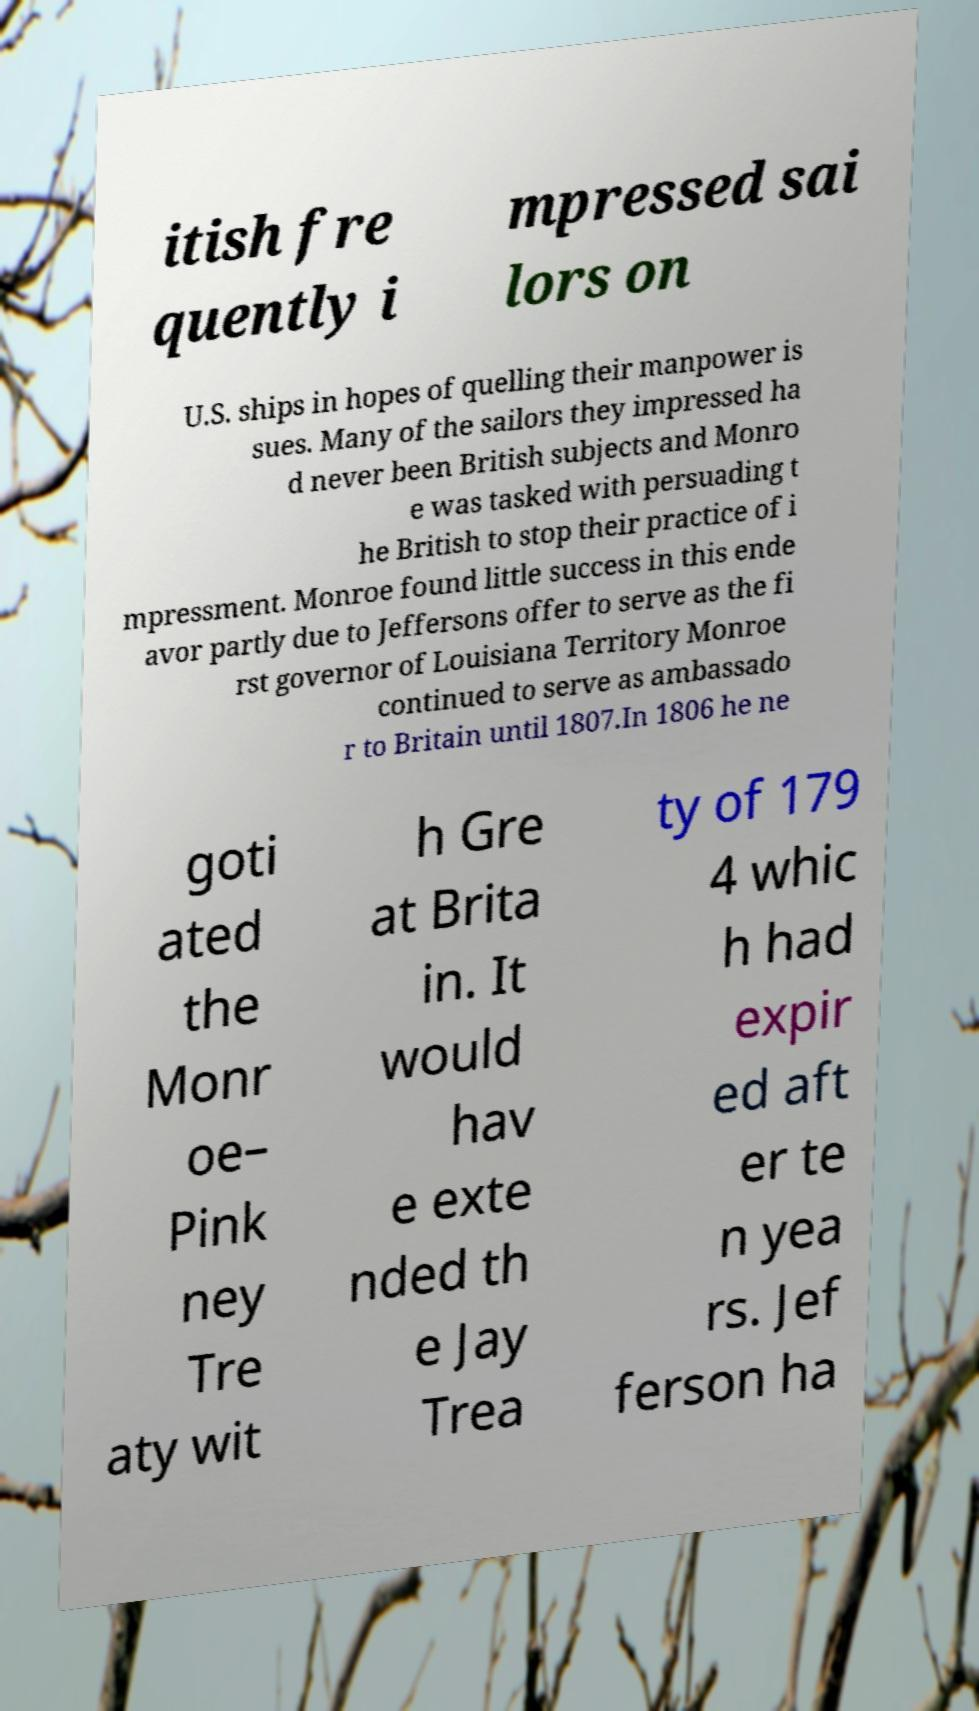I need the written content from this picture converted into text. Can you do that? itish fre quently i mpressed sai lors on U.S. ships in hopes of quelling their manpower is sues. Many of the sailors they impressed ha d never been British subjects and Monro e was tasked with persuading t he British to stop their practice of i mpressment. Monroe found little success in this ende avor partly due to Jeffersons offer to serve as the fi rst governor of Louisiana Territory Monroe continued to serve as ambassado r to Britain until 1807.In 1806 he ne goti ated the Monr oe– Pink ney Tre aty wit h Gre at Brita in. It would hav e exte nded th e Jay Trea ty of 179 4 whic h had expir ed aft er te n yea rs. Jef ferson ha 